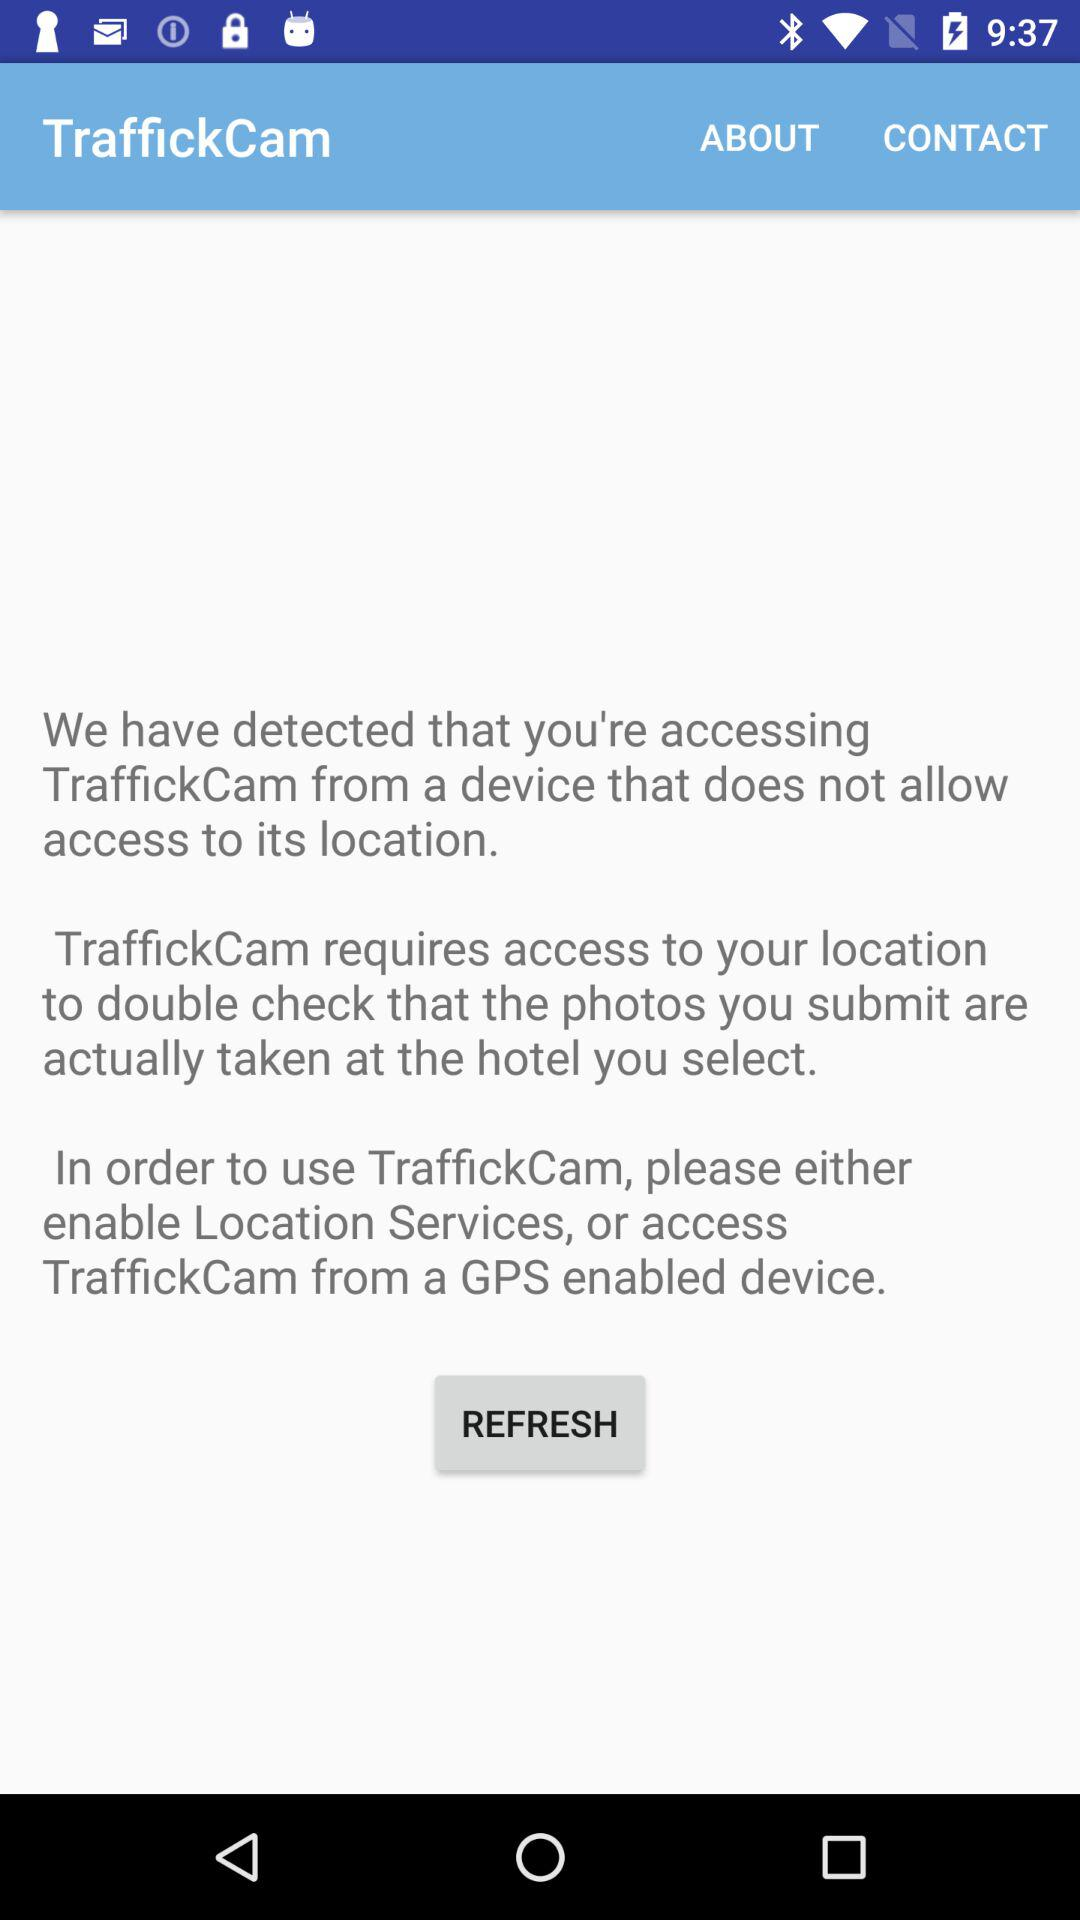What is the app name? The app name is "TraffickCam". 